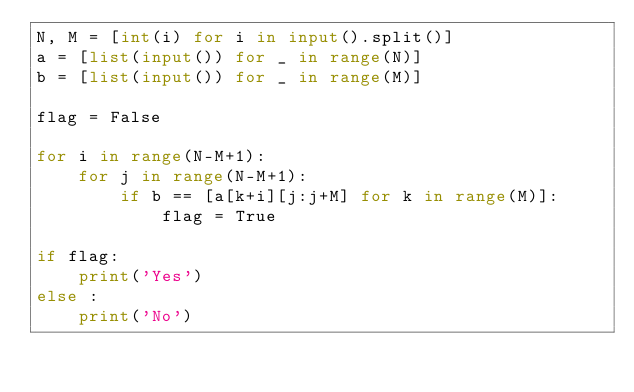Convert code to text. <code><loc_0><loc_0><loc_500><loc_500><_Python_>N, M = [int(i) for i in input().split()]
a = [list(input()) for _ in range(N)]
b = [list(input()) for _ in range(M)]

flag = False

for i in range(N-M+1):
    for j in range(N-M+1):
        if b == [a[k+i][j:j+M] for k in range(M)]:
            flag = True

if flag:
    print('Yes')
else :
    print('No')</code> 